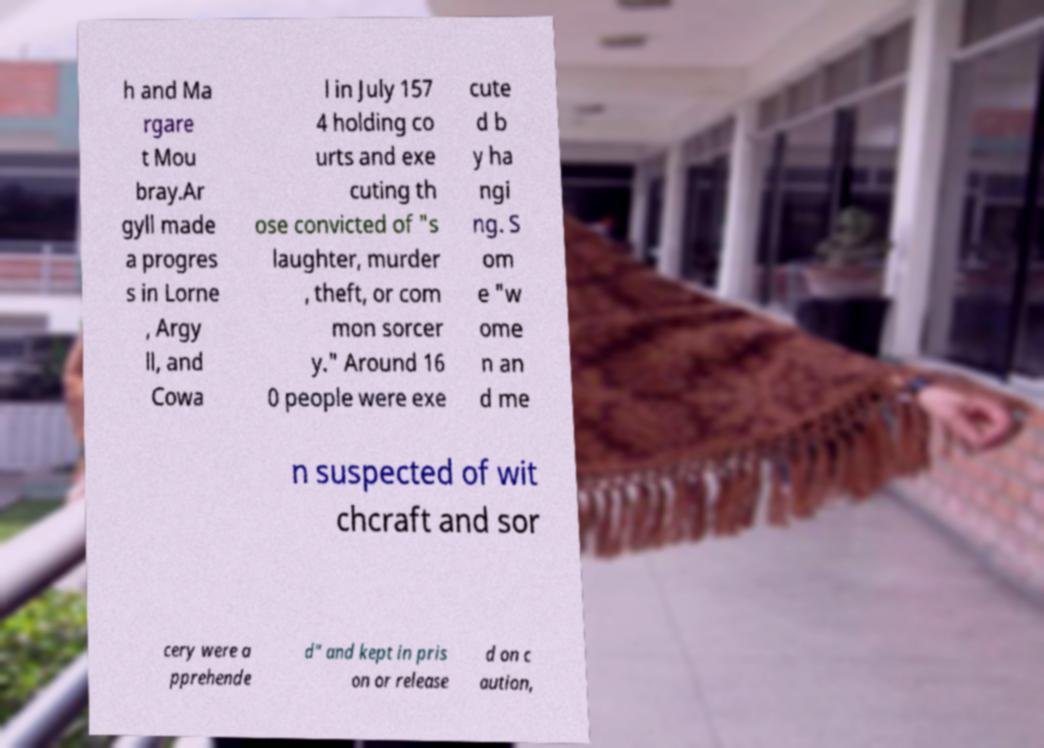For documentation purposes, I need the text within this image transcribed. Could you provide that? h and Ma rgare t Mou bray.Ar gyll made a progres s in Lorne , Argy ll, and Cowa l in July 157 4 holding co urts and exe cuting th ose convicted of "s laughter, murder , theft, or com mon sorcer y." Around 16 0 people were exe cute d b y ha ngi ng. S om e "w ome n an d me n suspected of wit chcraft and sor cery were a pprehende d" and kept in pris on or release d on c aution, 